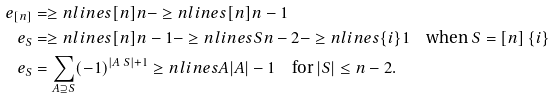<formula> <loc_0><loc_0><loc_500><loc_500>e _ { [ n ] } & = \geq n l i n e s { [ n ] } { n } - \geq n l i n e s { [ n ] } { n - 1 } \\ e _ { S } & = \geq n l i n e s { [ n ] } { n - 1 } - \geq n l i n e s { S } { n - 2 } - \geq n l i n e s { \{ i \} } { 1 } \quad \text {when } S = [ n ] \ \{ i \} \\ e _ { S } & = \sum _ { A \supseteq S } ( - 1 ) ^ { | A \ S | + 1 } \geq n l i n e s { A } { | A | - 1 } \quad \text {for } | S | \leq n - 2 .</formula> 